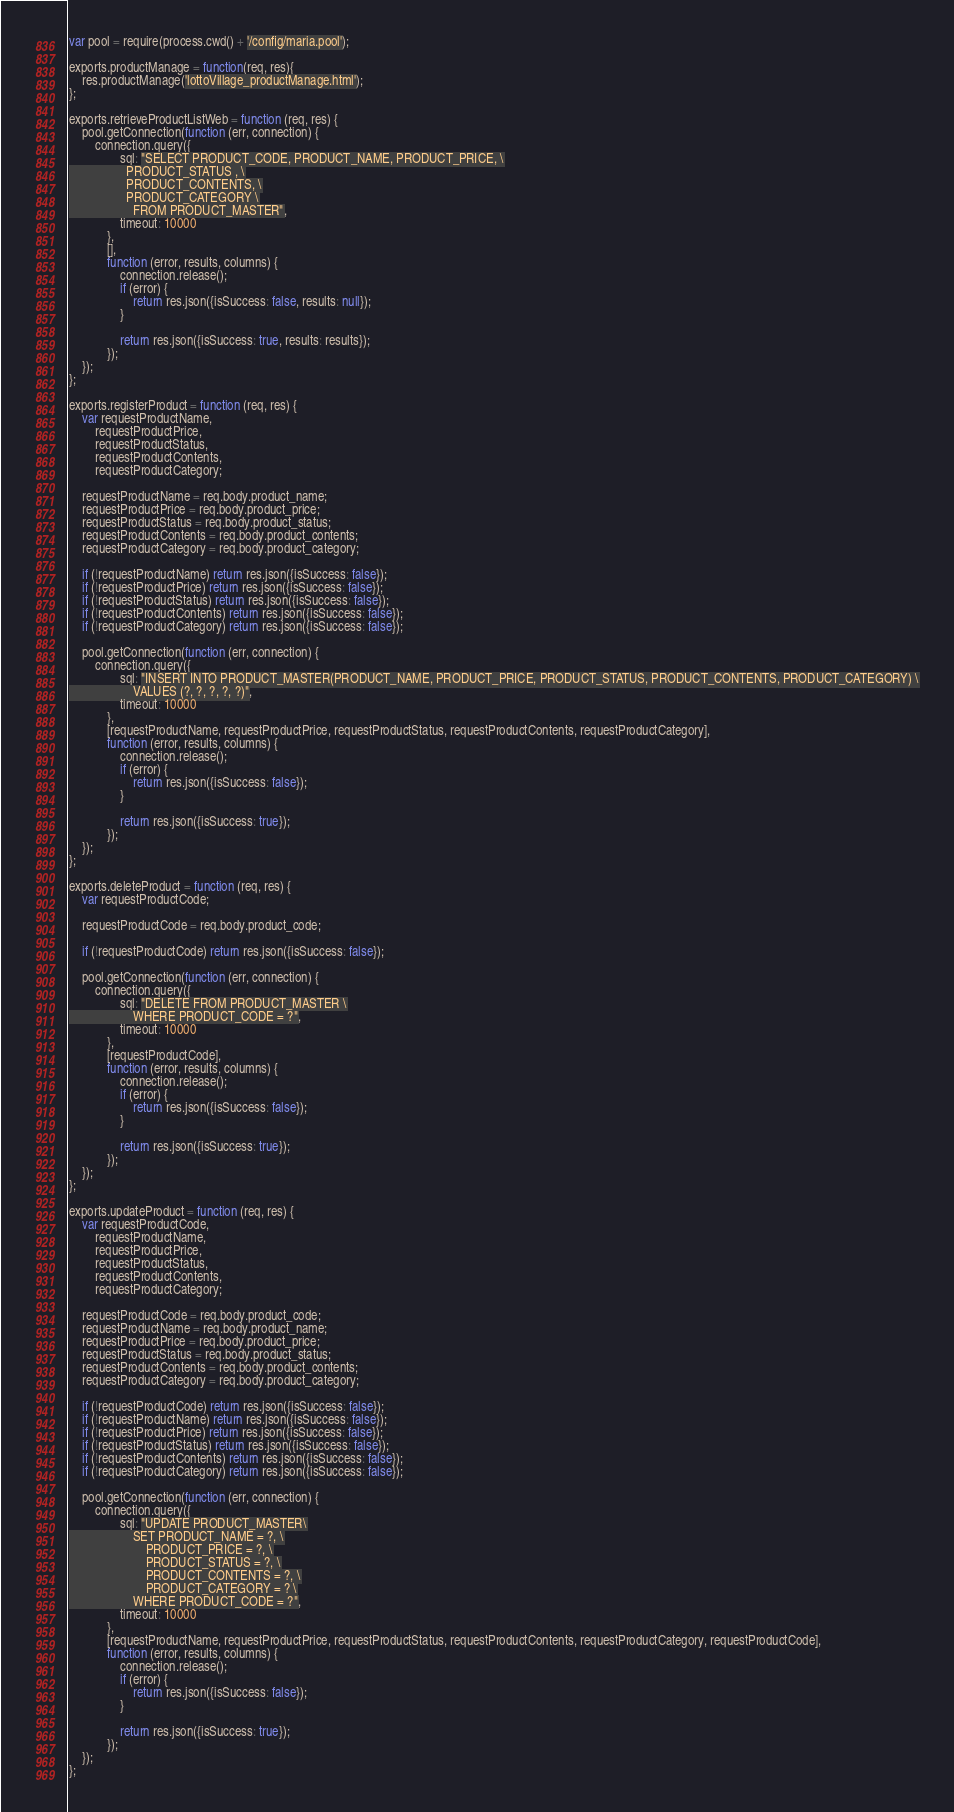Convert code to text. <code><loc_0><loc_0><loc_500><loc_500><_JavaScript_>var pool = require(process.cwd() + '/config/maria.pool');

exports.productManage = function(req, res){
    res.productManage('lottoVillage_productManage.html');
};

exports.retrieveProductListWeb = function (req, res) {
    pool.getConnection(function (err, connection) {
        connection.query({
                sql: "SELECT PRODUCT_CODE, PRODUCT_NAME, PRODUCT_PRICE, \
                  PRODUCT_STATUS , \
                  PRODUCT_CONTENTS, \
                  PRODUCT_CATEGORY \
                    FROM PRODUCT_MASTER",
                timeout: 10000
            },
            [],
            function (error, results, columns) {
                connection.release();
                if (error) {
                    return res.json({isSuccess: false, results: null});
                }

                return res.json({isSuccess: true, results: results});
            });
    });
};

exports.registerProduct = function (req, res) {
    var requestProductName,
        requestProductPrice,
        requestProductStatus,
        requestProductContents,
        requestProductCategory;

    requestProductName = req.body.product_name;
    requestProductPrice = req.body.product_price;
    requestProductStatus = req.body.product_status;
    requestProductContents = req.body.product_contents;
    requestProductCategory = req.body.product_category;

    if (!requestProductName) return res.json({isSuccess: false});
    if (!requestProductPrice) return res.json({isSuccess: false});
    if (!requestProductStatus) return res.json({isSuccess: false});
    if (!requestProductContents) return res.json({isSuccess: false});
    if (!requestProductCategory) return res.json({isSuccess: false});

    pool.getConnection(function (err, connection) {
        connection.query({
                sql: "INSERT INTO PRODUCT_MASTER(PRODUCT_NAME, PRODUCT_PRICE, PRODUCT_STATUS, PRODUCT_CONTENTS, PRODUCT_CATEGORY) \
                    VALUES (?, ?, ?, ?, ?)",
                timeout: 10000
            },
            [requestProductName, requestProductPrice, requestProductStatus, requestProductContents, requestProductCategory],
            function (error, results, columns) {
                connection.release();
                if (error) {
                    return res.json({isSuccess: false});
                }

                return res.json({isSuccess: true});
            });
    });
};

exports.deleteProduct = function (req, res) {
    var requestProductCode;

    requestProductCode = req.body.product_code;

    if (!requestProductCode) return res.json({isSuccess: false});

    pool.getConnection(function (err, connection) {
        connection.query({
                sql: "DELETE FROM PRODUCT_MASTER \
                    WHERE PRODUCT_CODE = ?",
                timeout: 10000
            },
            [requestProductCode],
            function (error, results, columns) {
                connection.release();
                if (error) {
                    return res.json({isSuccess: false});
                }

                return res.json({isSuccess: true});
            });
    });
};

exports.updateProduct = function (req, res) {
    var requestProductCode,
        requestProductName,
        requestProductPrice,
        requestProductStatus,
        requestProductContents,
        requestProductCategory;

    requestProductCode = req.body.product_code;
    requestProductName = req.body.product_name;
    requestProductPrice = req.body.product_price;
    requestProductStatus = req.body.product_status;
    requestProductContents = req.body.product_contents;
    requestProductCategory = req.body.product_category;

    if (!requestProductCode) return res.json({isSuccess: false});
    if (!requestProductName) return res.json({isSuccess: false});
    if (!requestProductPrice) return res.json({isSuccess: false});
    if (!requestProductStatus) return res.json({isSuccess: false});
    if (!requestProductContents) return res.json({isSuccess: false});
    if (!requestProductCategory) return res.json({isSuccess: false});

    pool.getConnection(function (err, connection) {
        connection.query({
                sql: "UPDATE PRODUCT_MASTER\
                    SET PRODUCT_NAME = ?, \
                        PRODUCT_PRICE = ?, \
                        PRODUCT_STATUS = ?, \
                        PRODUCT_CONTENTS = ?, \
                        PRODUCT_CATEGORY = ? \
                    WHERE PRODUCT_CODE = ?",
                timeout: 10000
            },
            [requestProductName, requestProductPrice, requestProductStatus, requestProductContents, requestProductCategory, requestProductCode],
            function (error, results, columns) {
                connection.release();
                if (error) {
                    return res.json({isSuccess: false});
                }

                return res.json({isSuccess: true});
            });
    });
};</code> 